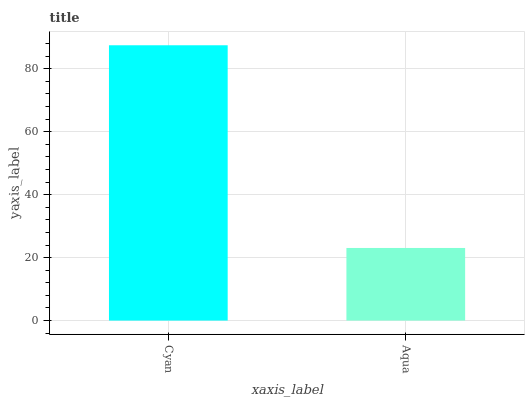Is Aqua the minimum?
Answer yes or no. Yes. Is Cyan the maximum?
Answer yes or no. Yes. Is Aqua the maximum?
Answer yes or no. No. Is Cyan greater than Aqua?
Answer yes or no. Yes. Is Aqua less than Cyan?
Answer yes or no. Yes. Is Aqua greater than Cyan?
Answer yes or no. No. Is Cyan less than Aqua?
Answer yes or no. No. Is Cyan the high median?
Answer yes or no. Yes. Is Aqua the low median?
Answer yes or no. Yes. Is Aqua the high median?
Answer yes or no. No. Is Cyan the low median?
Answer yes or no. No. 